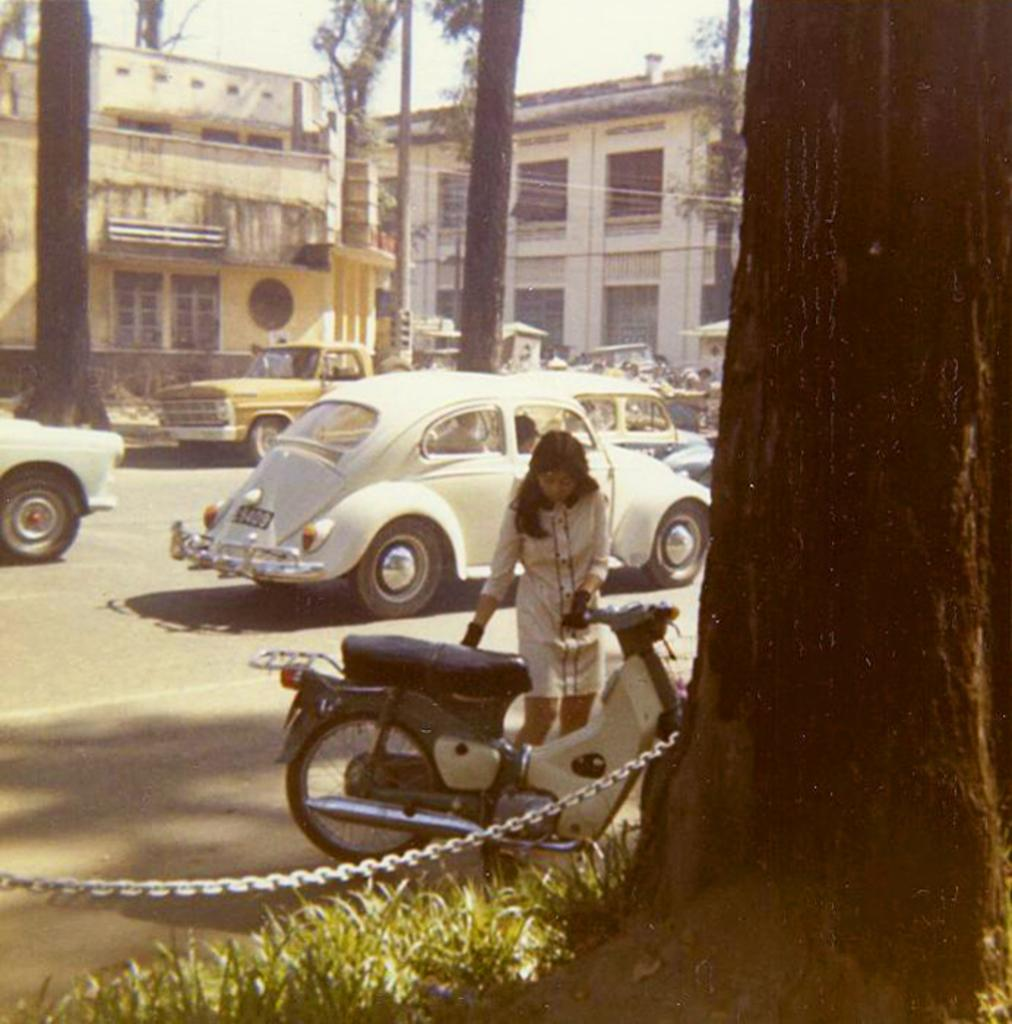Who or what can be seen in the image? There are people in the image. What else can be seen on the ground in the image? There are vehicles on the road in the image. What type of structures are visible in the image? There are houses in the image. Can you describe any specific features of the houses? There are windows in the image. What type of vegetation is present in the image? There are trees in the image. What type of ground cover is present in the image? There is grass in the image. Is there any other object made of metal in the image? Yes, there is a metal chain in the image. What is visible at the top of the image? The sky is visible at the top of the image. What type of spark can be seen coming from the trees in the image? There is no spark present in the image; it features trees, grass, and other elements mentioned in the facts. What type of conversation or discussion is happening between the people in the image? The image does not show any indication of people talking or having a conversation. 